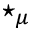<formula> <loc_0><loc_0><loc_500><loc_500>^ { * } _ { \mu }</formula> 